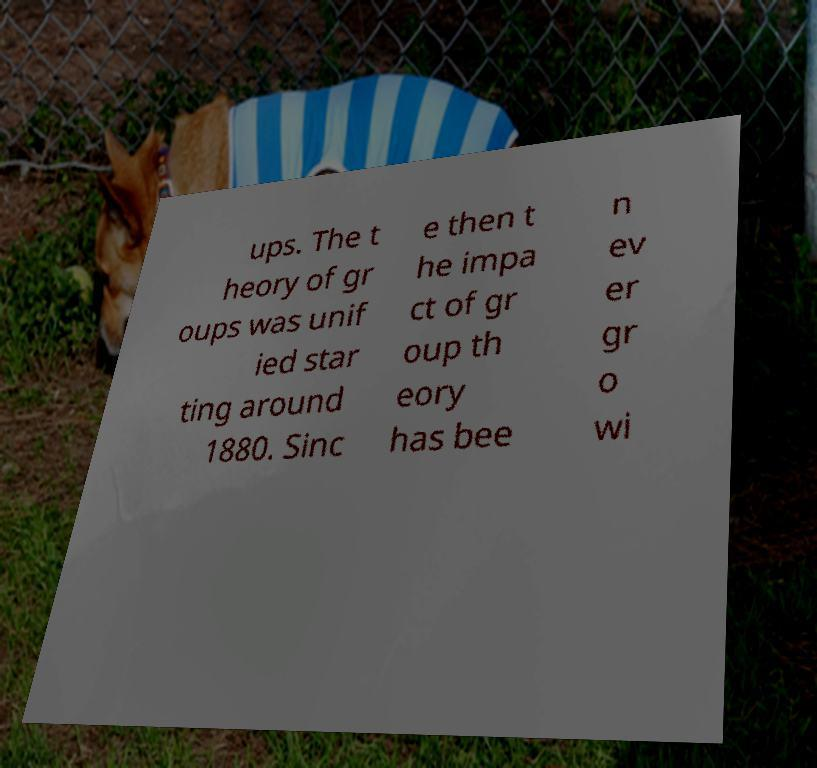Please identify and transcribe the text found in this image. ups. The t heory of gr oups was unif ied star ting around 1880. Sinc e then t he impa ct of gr oup th eory has bee n ev er gr o wi 